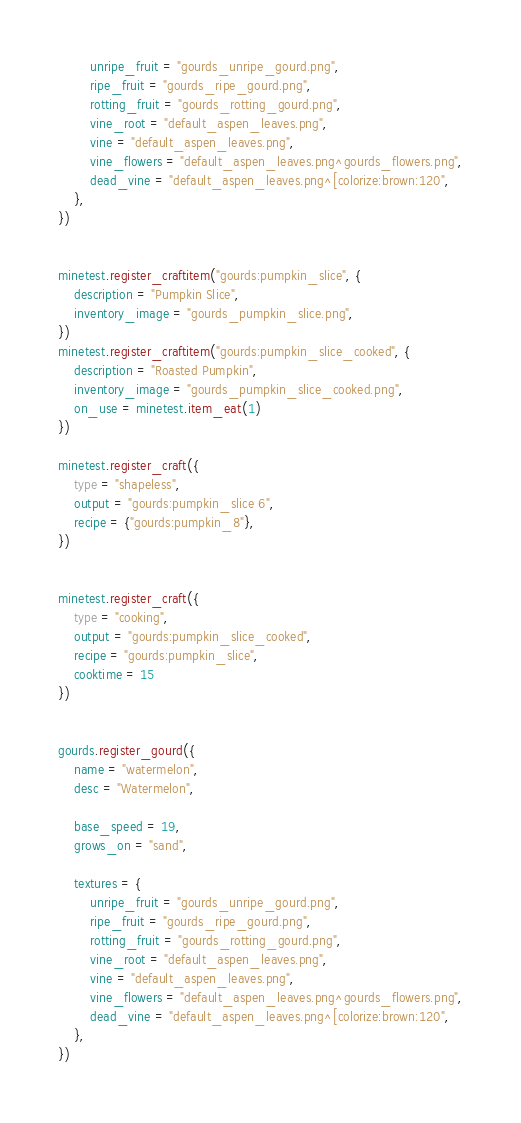Convert code to text. <code><loc_0><loc_0><loc_500><loc_500><_Lua_>		unripe_fruit = "gourds_unripe_gourd.png",
		ripe_fruit = "gourds_ripe_gourd.png",
		rotting_fruit = "gourds_rotting_gourd.png",
		vine_root = "default_aspen_leaves.png",
		vine = "default_aspen_leaves.png",
		vine_flowers = "default_aspen_leaves.png^gourds_flowers.png",
		dead_vine = "default_aspen_leaves.png^[colorize:brown:120",
	},
})


minetest.register_craftitem("gourds:pumpkin_slice", {
	description = "Pumpkin Slice",
	inventory_image = "gourds_pumpkin_slice.png",
})
minetest.register_craftitem("gourds:pumpkin_slice_cooked", {
	description = "Roasted Pumpkin",
	inventory_image = "gourds_pumpkin_slice_cooked.png",
	on_use = minetest.item_eat(1)
})

minetest.register_craft({
	type = "shapeless",
	output = "gourds:pumpkin_slice 6",
	recipe = {"gourds:pumpkin_8"},
})
	

minetest.register_craft({
	type = "cooking",
	output = "gourds:pumpkin_slice_cooked",
	recipe = "gourds:pumpkin_slice",
	cooktime = 15
})


gourds.register_gourd({
	name = "watermelon",
	desc = "Watermelon",
	
	base_speed = 19,
	grows_on = "sand",
	
	textures = {
		unripe_fruit = "gourds_unripe_gourd.png",
		ripe_fruit = "gourds_ripe_gourd.png",
		rotting_fruit = "gourds_rotting_gourd.png",
		vine_root = "default_aspen_leaves.png",
		vine = "default_aspen_leaves.png",
		vine_flowers = "default_aspen_leaves.png^gourds_flowers.png",
		dead_vine = "default_aspen_leaves.png^[colorize:brown:120",
	},
})




</code> 